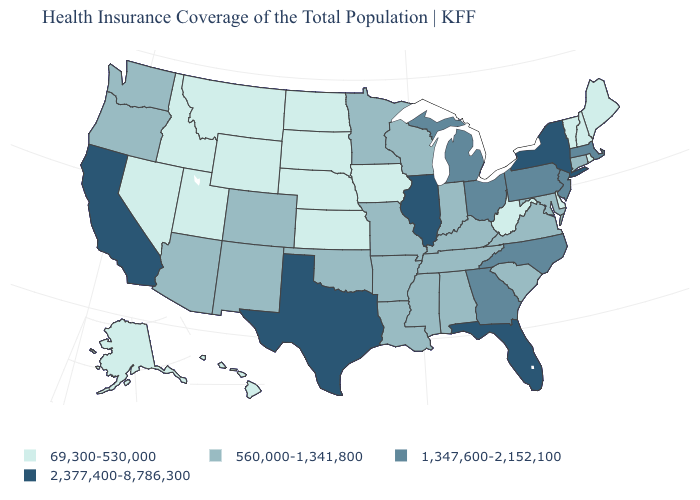Does Pennsylvania have the same value as Arkansas?
Keep it brief. No. What is the lowest value in states that border Montana?
Short answer required. 69,300-530,000. What is the value of North Dakota?
Be succinct. 69,300-530,000. Name the states that have a value in the range 69,300-530,000?
Short answer required. Alaska, Delaware, Hawaii, Idaho, Iowa, Kansas, Maine, Montana, Nebraska, Nevada, New Hampshire, North Dakota, Rhode Island, South Dakota, Utah, Vermont, West Virginia, Wyoming. Does New York have the highest value in the USA?
Concise answer only. Yes. Name the states that have a value in the range 1,347,600-2,152,100?
Give a very brief answer. Georgia, Massachusetts, Michigan, New Jersey, North Carolina, Ohio, Pennsylvania. Name the states that have a value in the range 2,377,400-8,786,300?
Quick response, please. California, Florida, Illinois, New York, Texas. Which states have the lowest value in the USA?
Write a very short answer. Alaska, Delaware, Hawaii, Idaho, Iowa, Kansas, Maine, Montana, Nebraska, Nevada, New Hampshire, North Dakota, Rhode Island, South Dakota, Utah, Vermont, West Virginia, Wyoming. Which states have the highest value in the USA?
Short answer required. California, Florida, Illinois, New York, Texas. Name the states that have a value in the range 560,000-1,341,800?
Short answer required. Alabama, Arizona, Arkansas, Colorado, Connecticut, Indiana, Kentucky, Louisiana, Maryland, Minnesota, Mississippi, Missouri, New Mexico, Oklahoma, Oregon, South Carolina, Tennessee, Virginia, Washington, Wisconsin. What is the lowest value in the USA?
Be succinct. 69,300-530,000. Name the states that have a value in the range 69,300-530,000?
Be succinct. Alaska, Delaware, Hawaii, Idaho, Iowa, Kansas, Maine, Montana, Nebraska, Nevada, New Hampshire, North Dakota, Rhode Island, South Dakota, Utah, Vermont, West Virginia, Wyoming. What is the lowest value in the USA?
Concise answer only. 69,300-530,000. Which states hav the highest value in the MidWest?
Answer briefly. Illinois. Does the first symbol in the legend represent the smallest category?
Give a very brief answer. Yes. 